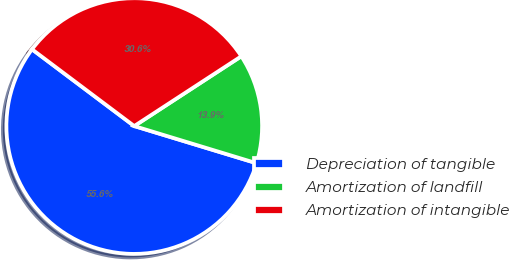Convert chart to OTSL. <chart><loc_0><loc_0><loc_500><loc_500><pie_chart><fcel>Depreciation of tangible<fcel>Amortization of landfill<fcel>Amortization of intangible<nl><fcel>55.56%<fcel>13.89%<fcel>30.56%<nl></chart> 